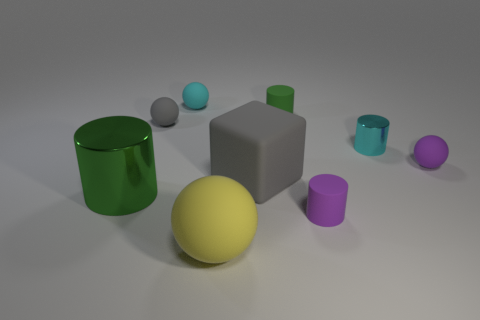Add 1 green shiny cylinders. How many objects exist? 10 Subtract all large spheres. How many spheres are left? 3 Subtract all purple balls. How many balls are left? 3 Subtract all blue spheres. How many green cylinders are left? 2 Subtract 1 blocks. How many blocks are left? 0 Subtract all purple cylinders. Subtract all green blocks. How many cylinders are left? 3 Subtract all purple rubber balls. Subtract all matte cylinders. How many objects are left? 6 Add 3 large gray rubber objects. How many large gray rubber objects are left? 4 Add 1 yellow matte things. How many yellow matte things exist? 2 Subtract 0 blue cylinders. How many objects are left? 9 